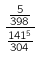Convert formula to latex. <formula><loc_0><loc_0><loc_500><loc_500>\frac { \frac { 5 } { 3 9 8 } } { \frac { 1 4 1 ^ { 5 } } { 3 0 4 } }</formula> 